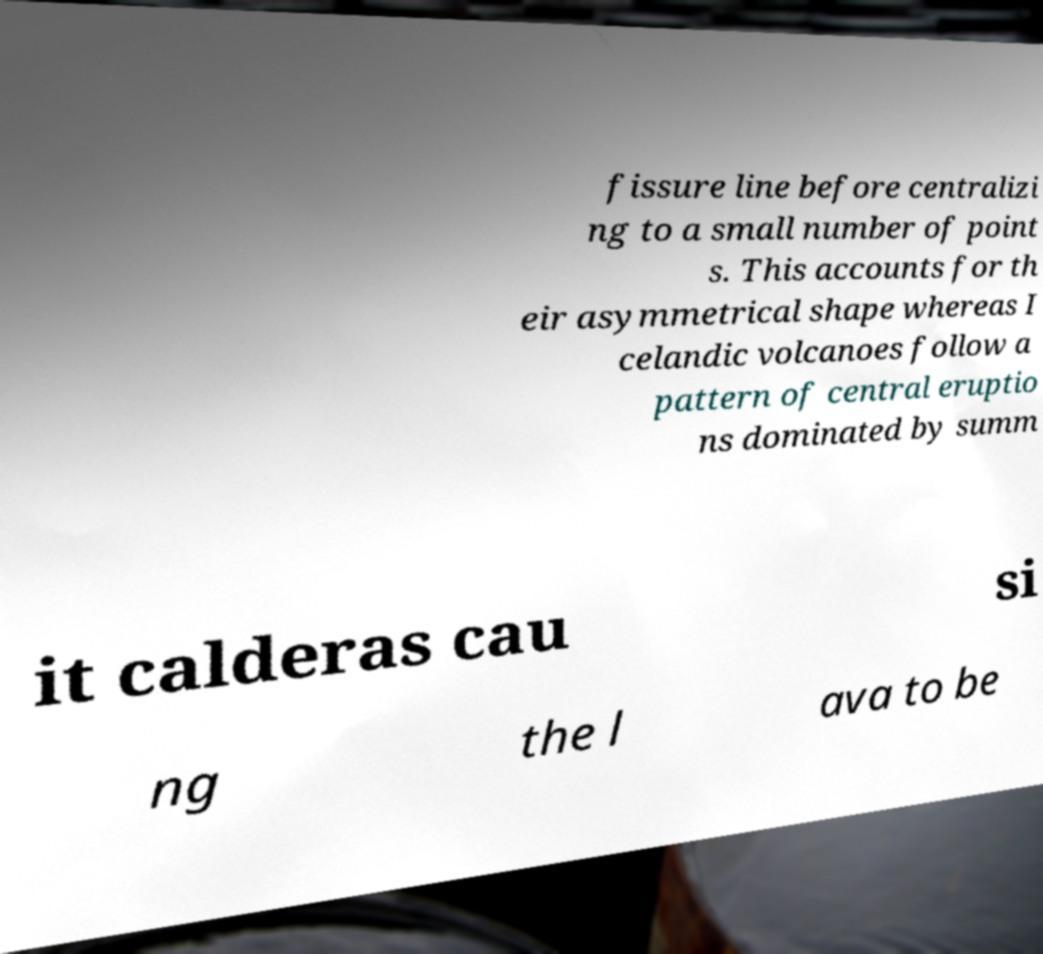Can you read and provide the text displayed in the image?This photo seems to have some interesting text. Can you extract and type it out for me? fissure line before centralizi ng to a small number of point s. This accounts for th eir asymmetrical shape whereas I celandic volcanoes follow a pattern of central eruptio ns dominated by summ it calderas cau si ng the l ava to be 